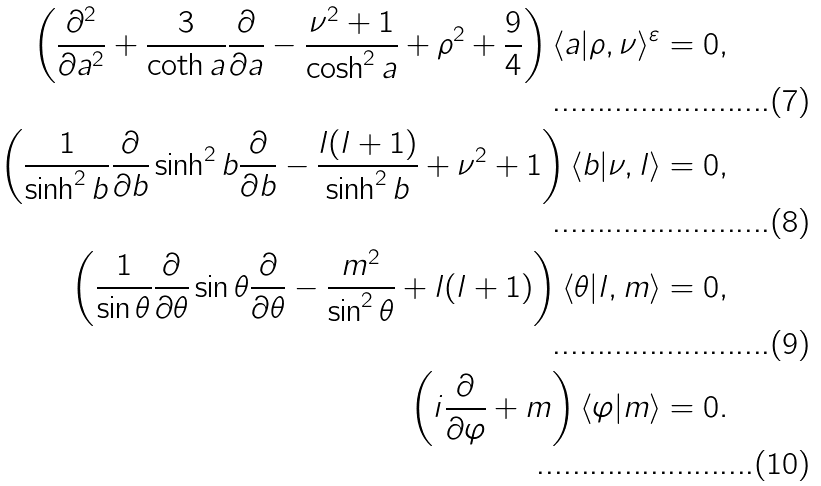Convert formula to latex. <formula><loc_0><loc_0><loc_500><loc_500>\left ( \frac { \partial ^ { 2 } } { \partial a ^ { 2 } } + \frac { 3 } { \coth a } \frac { \partial } { \partial a } - \frac { \nu ^ { 2 } + 1 } { \cosh ^ { 2 } a } + \rho ^ { 2 } + \frac { 9 } { 4 } \right ) \langle a | \rho , \nu \rangle ^ { \varepsilon } = 0 , \\ \left ( \frac { 1 } { \sinh ^ { 2 } b } \frac { \partial } { \partial b } \sinh ^ { 2 } b \frac { \partial } { \partial b } - \frac { l ( l + 1 ) } { \sinh ^ { 2 } b } + \nu ^ { 2 } + 1 \right ) \langle b | \nu , l \rangle = 0 , \\ \left ( \frac { 1 } { \sin \theta } \frac { \partial } { \partial \theta } \sin \theta \frac { \partial } { \partial \theta } - \frac { m ^ { 2 } } { \sin ^ { 2 } \theta } + l ( l + 1 ) \right ) \langle \theta | l , m \rangle = 0 , \\ \left ( i \frac { \partial } { \partial \varphi } + m \right ) \langle \varphi | m \rangle = 0 .</formula> 